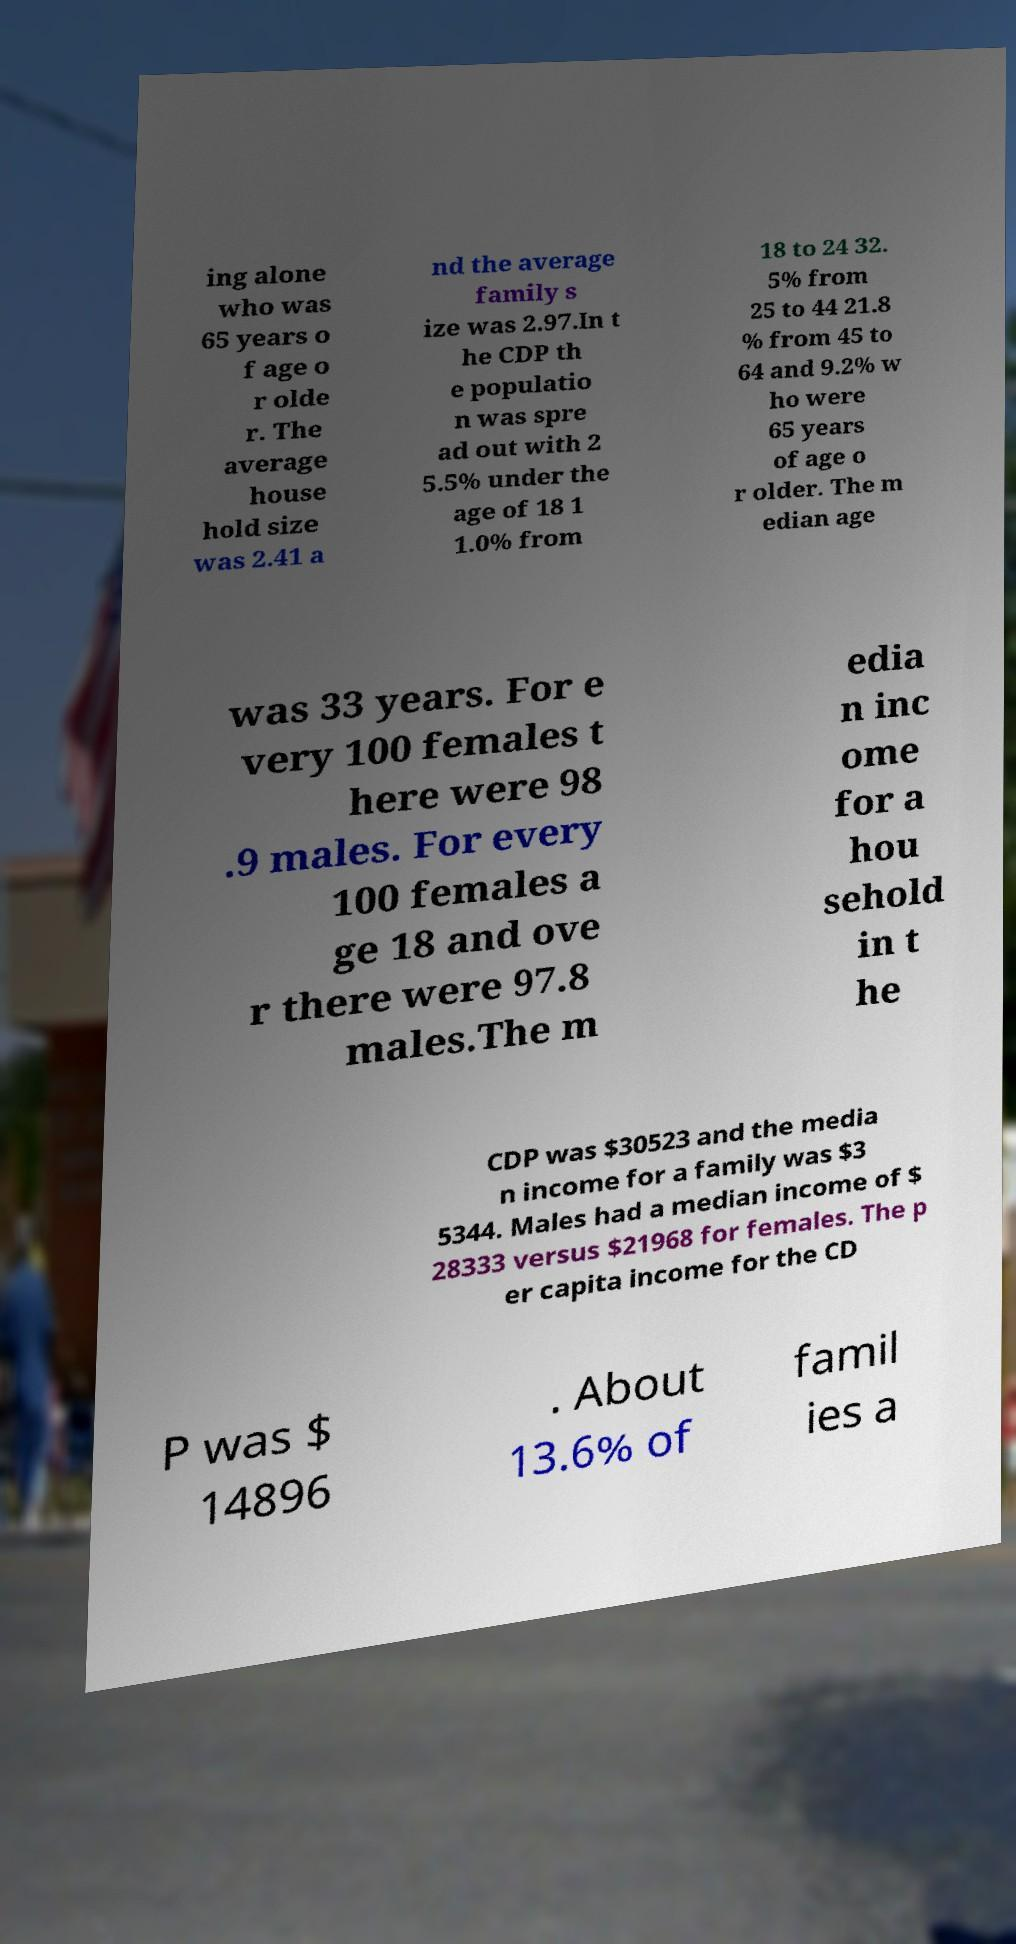For documentation purposes, I need the text within this image transcribed. Could you provide that? ing alone who was 65 years o f age o r olde r. The average house hold size was 2.41 a nd the average family s ize was 2.97.In t he CDP th e populatio n was spre ad out with 2 5.5% under the age of 18 1 1.0% from 18 to 24 32. 5% from 25 to 44 21.8 % from 45 to 64 and 9.2% w ho were 65 years of age o r older. The m edian age was 33 years. For e very 100 females t here were 98 .9 males. For every 100 females a ge 18 and ove r there were 97.8 males.The m edia n inc ome for a hou sehold in t he CDP was $30523 and the media n income for a family was $3 5344. Males had a median income of $ 28333 versus $21968 for females. The p er capita income for the CD P was $ 14896 . About 13.6% of famil ies a 